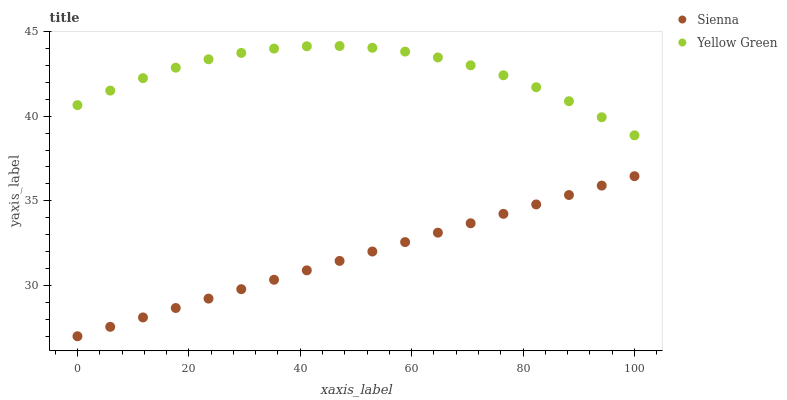Does Sienna have the minimum area under the curve?
Answer yes or no. Yes. Does Yellow Green have the maximum area under the curve?
Answer yes or no. Yes. Does Yellow Green have the minimum area under the curve?
Answer yes or no. No. Is Sienna the smoothest?
Answer yes or no. Yes. Is Yellow Green the roughest?
Answer yes or no. Yes. Is Yellow Green the smoothest?
Answer yes or no. No. Does Sienna have the lowest value?
Answer yes or no. Yes. Does Yellow Green have the lowest value?
Answer yes or no. No. Does Yellow Green have the highest value?
Answer yes or no. Yes. Is Sienna less than Yellow Green?
Answer yes or no. Yes. Is Yellow Green greater than Sienna?
Answer yes or no. Yes. Does Sienna intersect Yellow Green?
Answer yes or no. No. 